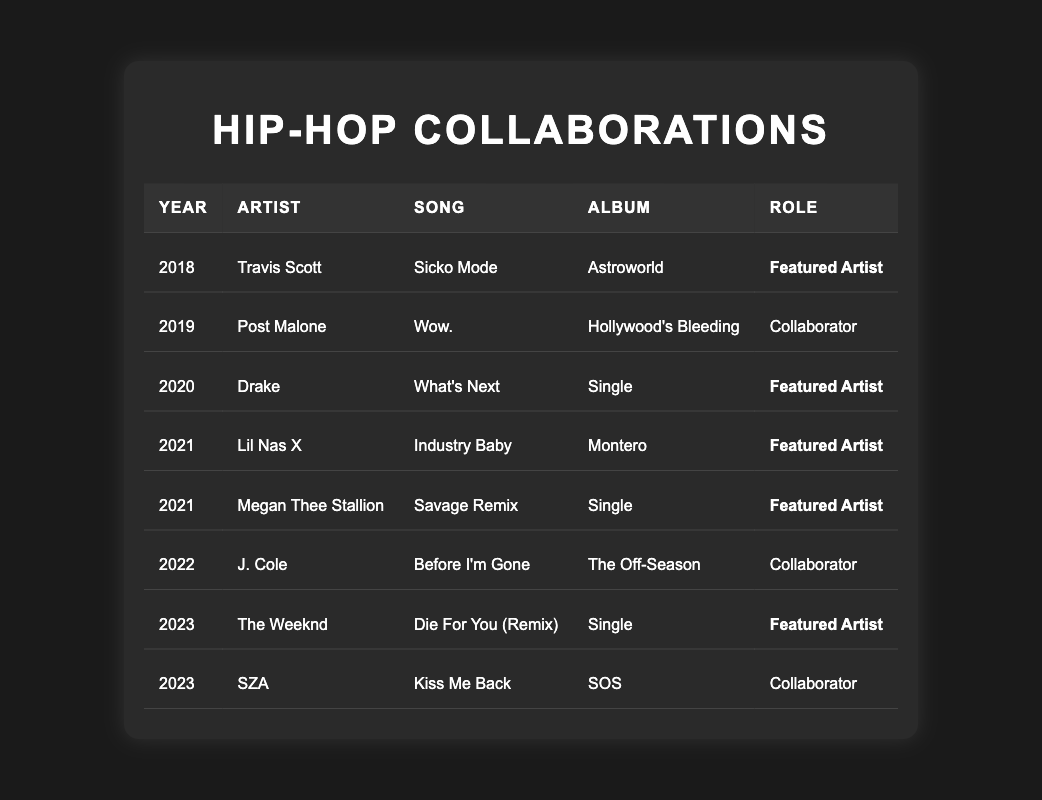What year did you collaborate with Travis Scott? Travis Scott is listed in the table under the year 2018 for the song "Sicko Mode."
Answer: 2018 How many collaborations involved you as a featured artist? By checking the roles in the table, "Featured Artist" occurs 5 times across 2018 to 2023, indicating 5 collaborations where you were featured.
Answer: 5 Which song was released in 2022? In the year 2022, the table lists "Before I'm Gone" with J. Cole under the album "The Off-Season."
Answer: Before I'm Gone Did you collaborate with SZA? Yes, SZA is listed in the table as a collaborator for the song "Kiss Me Back" in 2023.
Answer: Yes Which year had the most collaborators listed? Analyzing the entries, both 2019 and 2022 have one collaborator each, but the year with the most collaborations where you were featured as an artist is 2021.
Answer: 2021 What is the difference in the number of collaborations in 2020 and 2021? In 2020, there was 1 collaboration (Drake), and in 2021 there were 3 (Lil Nas X, Megan Thee Stallion, and you), resulting in a difference of 3 - 1 = 2.
Answer: 2 What percentage of your collaborations were features? You had 5 featured roles out of a total of 8 collaborations (5 featured + 3 collaborators). So, the percentage is (5/8) * 100 = 62.5%.
Answer: 62.5% Which artist collaborated on the most songs with you? Analyzing data, you collaborated with multiple artists, but none had more than one song listed, thus no single artist collaborated on multiple songs.
Answer: None In which year did you feature on both a single and an album? After going through the table, 2021 is the year where you were featured on singles (Megan Thee Stallion) and also collaborated (Lil Nas X).
Answer: 2021 Was "Sicko Mode" part of an album? Yes, the table states "Sicko Mode" was part of the album "Astroworld."
Answer: Yes 